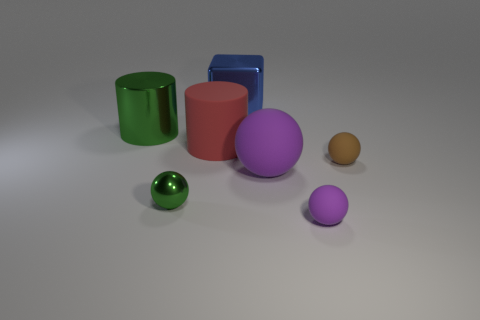Do the green ball and the purple matte ball on the right side of the large purple object have the same size?
Offer a terse response. Yes. What shape is the big matte thing on the right side of the big blue shiny thing?
Provide a short and direct response. Sphere. There is a tiny rubber ball that is behind the small matte object on the left side of the brown rubber sphere; is there a small purple thing that is right of it?
Give a very brief answer. No. There is another purple thing that is the same shape as the tiny purple thing; what is its material?
Offer a terse response. Rubber. Is there any other thing that is the same material as the tiny brown object?
Provide a short and direct response. Yes. How many spheres are big green shiny things or blue metallic things?
Your answer should be very brief. 0. There is a sphere left of the blue metal block; is its size the same as the green shiny thing behind the tiny brown rubber sphere?
Ensure brevity in your answer.  No. There is a green thing that is on the left side of the metallic thing that is in front of the brown object; what is it made of?
Give a very brief answer. Metal. Is the number of metal balls to the right of the small brown matte sphere less than the number of brown things?
Give a very brief answer. Yes. The tiny purple thing that is the same material as the red object is what shape?
Provide a short and direct response. Sphere. 